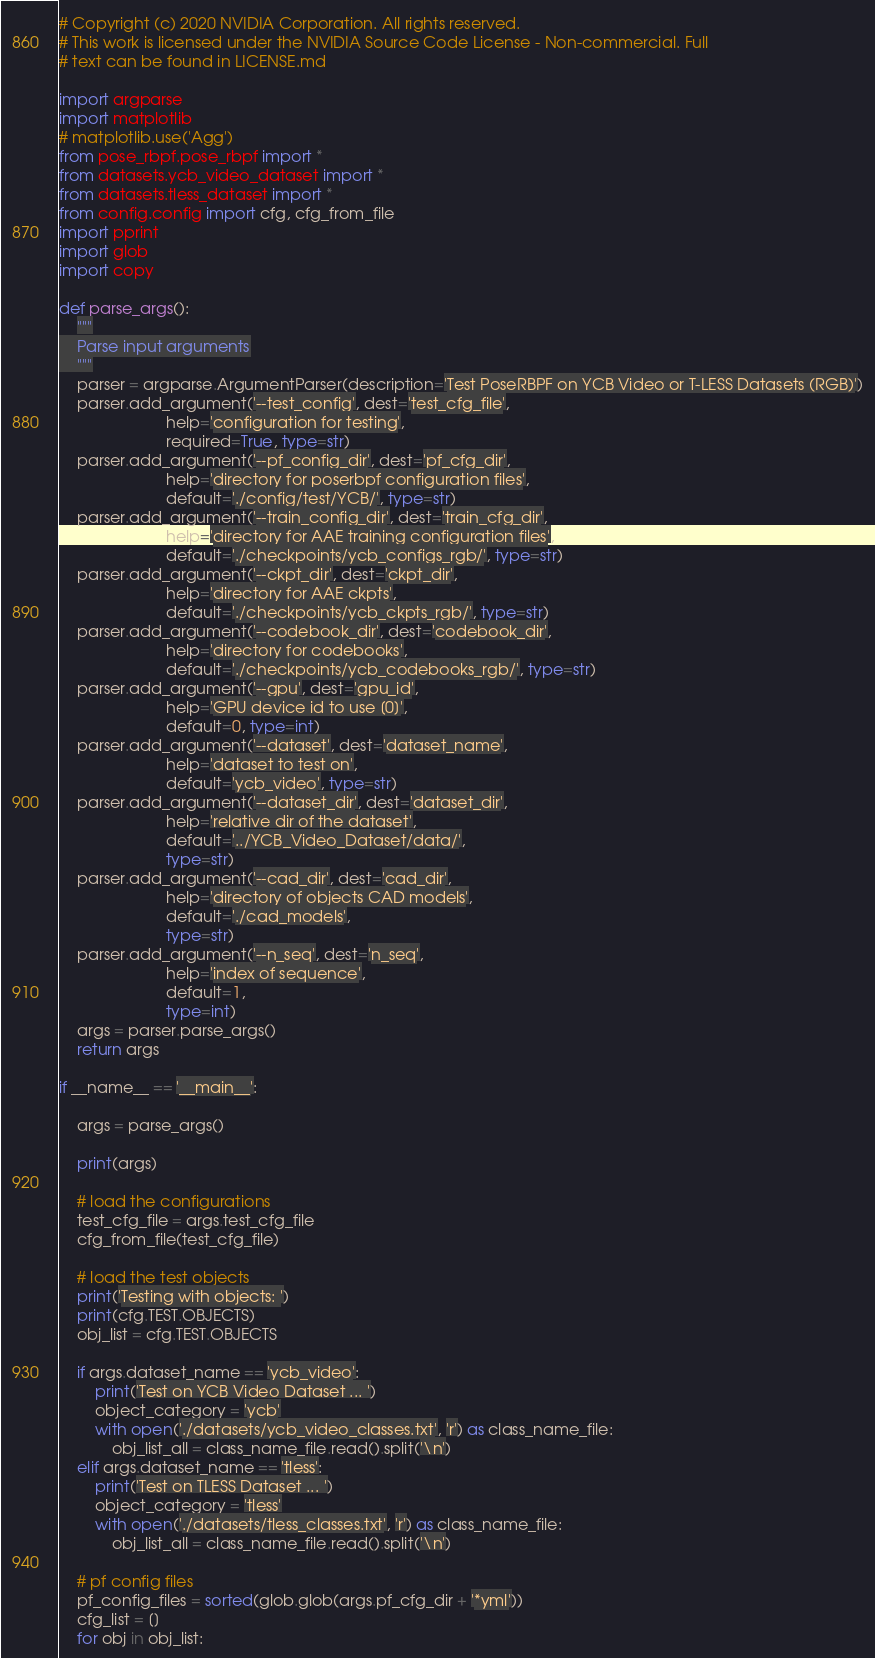<code> <loc_0><loc_0><loc_500><loc_500><_Python_># Copyright (c) 2020 NVIDIA Corporation. All rights reserved.
# This work is licensed under the NVIDIA Source Code License - Non-commercial. Full
# text can be found in LICENSE.md

import argparse
import matplotlib
# matplotlib.use('Agg')
from pose_rbpf.pose_rbpf import *
from datasets.ycb_video_dataset import *
from datasets.tless_dataset import *
from config.config import cfg, cfg_from_file
import pprint
import glob
import copy

def parse_args():
    """
    Parse input arguments
    """
    parser = argparse.ArgumentParser(description='Test PoseRBPF on YCB Video or T-LESS Datasets (RGB)')
    parser.add_argument('--test_config', dest='test_cfg_file',
                        help='configuration for testing',
                        required=True, type=str)
    parser.add_argument('--pf_config_dir', dest='pf_cfg_dir',
                        help='directory for poserbpf configuration files',
                        default='./config/test/YCB/', type=str)
    parser.add_argument('--train_config_dir', dest='train_cfg_dir',
                        help='directory for AAE training configuration files',
                        default='./checkpoints/ycb_configs_rgb/', type=str)
    parser.add_argument('--ckpt_dir', dest='ckpt_dir',
                        help='directory for AAE ckpts',
                        default='./checkpoints/ycb_ckpts_rgb/', type=str)
    parser.add_argument('--codebook_dir', dest='codebook_dir',
                        help='directory for codebooks',
                        default='./checkpoints/ycb_codebooks_rgb/', type=str)
    parser.add_argument('--gpu', dest='gpu_id',
                        help='GPU device id to use [0]',
                        default=0, type=int)
    parser.add_argument('--dataset', dest='dataset_name',
                        help='dataset to test on',
                        default='ycb_video', type=str)
    parser.add_argument('--dataset_dir', dest='dataset_dir',
                        help='relative dir of the dataset',
                        default='../YCB_Video_Dataset/data/',
                        type=str)
    parser.add_argument('--cad_dir', dest='cad_dir',
                        help='directory of objects CAD models',
                        default='./cad_models',
                        type=str)
    parser.add_argument('--n_seq', dest='n_seq',
                        help='index of sequence',
                        default=1,
                        type=int)
    args = parser.parse_args()
    return args

if __name__ == '__main__':

    args = parse_args()

    print(args)

    # load the configurations
    test_cfg_file = args.test_cfg_file
    cfg_from_file(test_cfg_file)

    # load the test objects
    print('Testing with objects: ')
    print(cfg.TEST.OBJECTS)
    obj_list = cfg.TEST.OBJECTS

    if args.dataset_name == 'ycb_video':
        print('Test on YCB Video Dataset ... ')
        object_category = 'ycb'
        with open('./datasets/ycb_video_classes.txt', 'r') as class_name_file:
            obj_list_all = class_name_file.read().split('\n')
    elif args.dataset_name == 'tless':
        print('Test on TLESS Dataset ... ')
        object_category = 'tless'
        with open('./datasets/tless_classes.txt', 'r') as class_name_file:
            obj_list_all = class_name_file.read().split('\n')

    # pf config files
    pf_config_files = sorted(glob.glob(args.pf_cfg_dir + '*yml'))
    cfg_list = []
    for obj in obj_list:</code> 